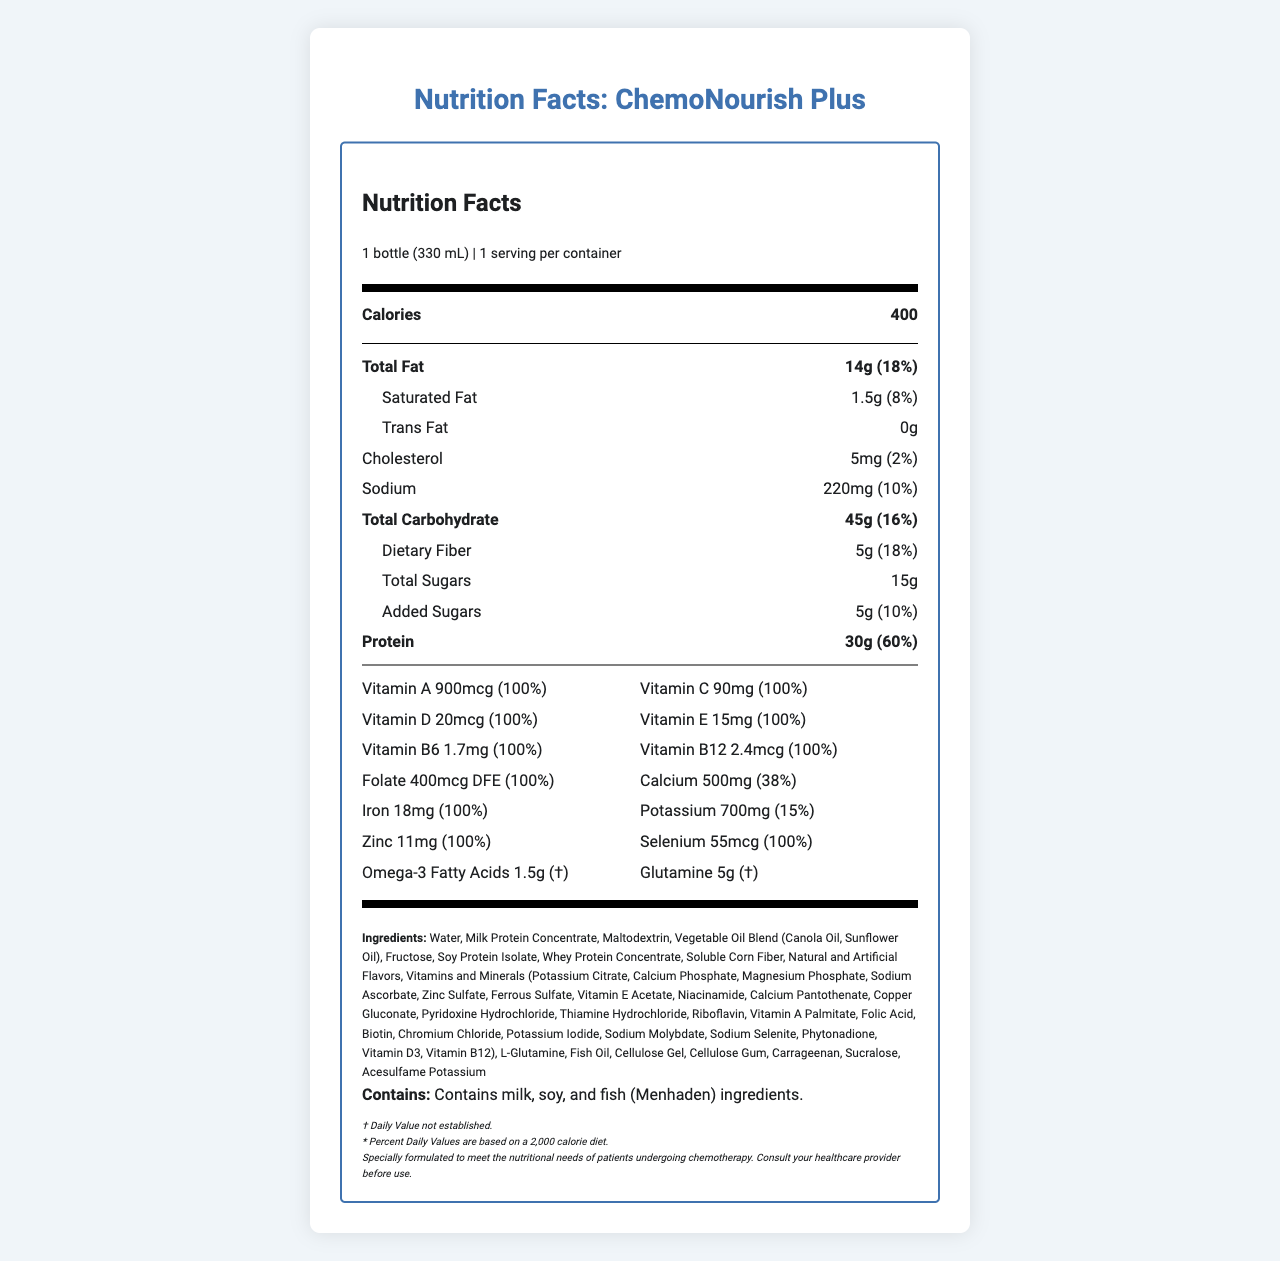what is the serving size of ChemoNourish Plus? The serving size is clearly mentioned in the nutrition label as 1 bottle (330 mL).
Answer: 1 bottle (330 mL) what is the amount of protein in one serving? The amount of protein is listed as 30g in one serving on the nutrition label.
Answer: 30g how much saturated fat does one bottle contain? The saturated fat content is indicated as 1.5g on the nutrition label.
Answer: 1.5g does the product contain any trans fat? The label states that the trans fat content is 0g, meaning there is no trans fat in the product.
Answer: No what is the amount of added sugars in ChemoNourish Plus? The amount of added sugars is specified as 5g on the label.
Answer: 5g is this product suitable for a person with a soy allergy? The allergen statement lists soy as an ingredient, making it unsuitable for someone with a soy allergy.
Answer: No what percentage of the daily value for calcium does one serving provide? The label specifies that one serving provides 38% of the daily value for calcium.
Answer: 38% what are the main sources of fat in this product? A. Milk protein concentrate, Soy Protein Isolate B. Fish Oil, Vegetable Oil Blend C. Maltodextrin, Acesulfame Potassium The ingredient list includes a Vegetable Oil Blend and Fish Oil as the main sources of fat.
Answer: B what is the total number of calories in one serving of ChemoNourish Plus? According to the nutrition label, one serving contains 400 calories.
Answer: 400 calories how much fiber is in one bottle? The dietary fiber content is indicated as 5g in one bottle on the label.
Answer: 5g what is the amount of iron provided in one serving? The label specifically mentions that one serving contains 18mg of iron.
Answer: 18mg what vitamins are provided at 100% of the daily value in ChemoNourish Plus? The vitamins listed are all provided at 100% of the daily value as indicated on the nutrition label.
Answer: Vitamin A, Vitamin C, Vitamin D, Vitamin E, Vitamin B6, Vitamin B12, Folate, Iron, Zinc, Selenium how much sodium is in one serving, and what percentage of the daily value does it represent? The label states there are 220mg of sodium per serving, which represents 10% of the daily recommended value.
Answer: 220mg, 10% summarize the nutrition profile of ChemoNourish Plus. This summary encapsulates the core nutritional attributes and target demographic of the product.
Answer: ChemoNourish Plus is a meal replacement shake designed for patients undergoing chemotherapy. It contains 400 calories per serving, with 14g total fat, 1.5g saturated fat, and 30g protein. It's enriched with essential vitamins and minerals, providing 100% of the daily value for many including Vitamin A, Vitamin C, Vitamin D, Vitamin E, and Iron. The product also includes omega-3 fatty acids and glutamine, with a focus on meeting the nutritional needs of chemotherapy patients. how does the presence of fish oil benefit patients, particularly those undergoing chemotherapy? The document lists fish oil among the ingredients, but it does not provide detailed information about its specific benefits for chemotherapy patients.
Answer: Not enough information 